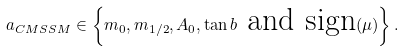Convert formula to latex. <formula><loc_0><loc_0><loc_500><loc_500>a _ { C M S S M } \in \left \{ m _ { 0 } , m _ { 1 / 2 } , A _ { 0 } , \tan b \text { and sign} ( \mu ) \right \} .</formula> 